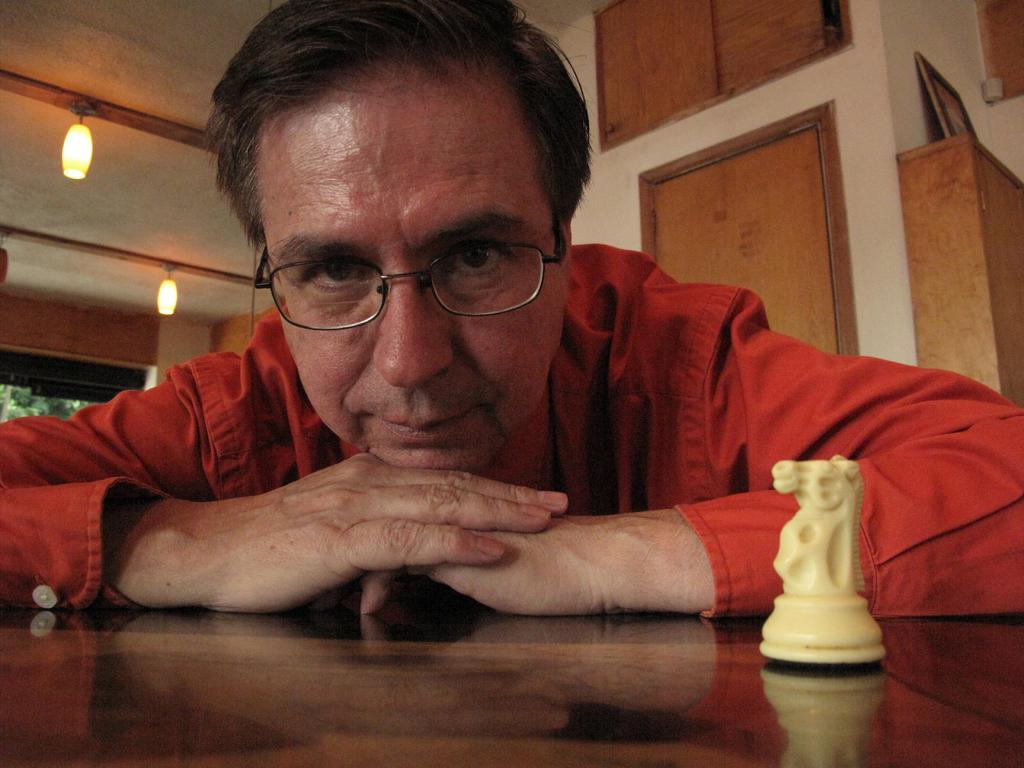Could you give a brief overview of what you see in this image? In this image I can see the brown color surface in front on which there is a chess coin and I can see a man who is wearing a red color shirt. In the background I can see the ceiling on which there are lights and I can see the wall and a photo frame on the right side of this picture and it is on a brown color thing. 